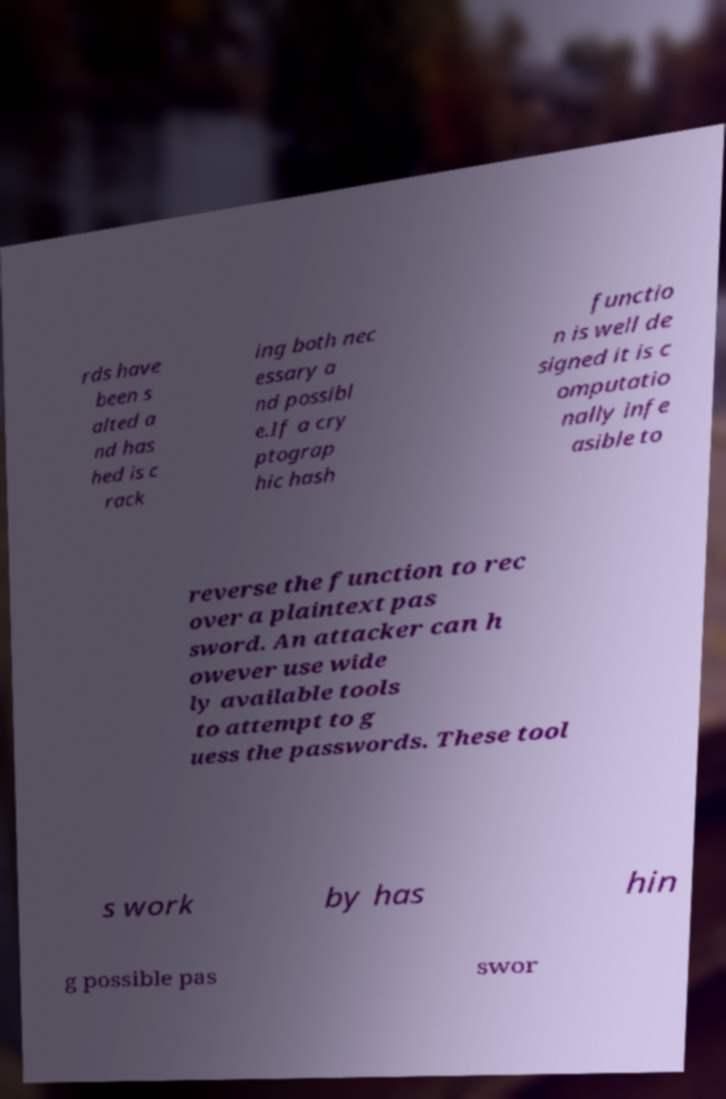For documentation purposes, I need the text within this image transcribed. Could you provide that? rds have been s alted a nd has hed is c rack ing both nec essary a nd possibl e.If a cry ptograp hic hash functio n is well de signed it is c omputatio nally infe asible to reverse the function to rec over a plaintext pas sword. An attacker can h owever use wide ly available tools to attempt to g uess the passwords. These tool s work by has hin g possible pas swor 